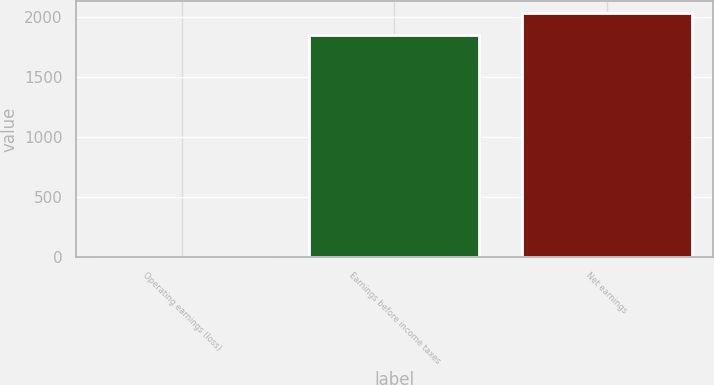<chart> <loc_0><loc_0><loc_500><loc_500><bar_chart><fcel>Operating earnings (loss)<fcel>Earnings before income taxes<fcel>Net earnings<nl><fcel>2.5<fcel>1848.7<fcel>2033.32<nl></chart> 